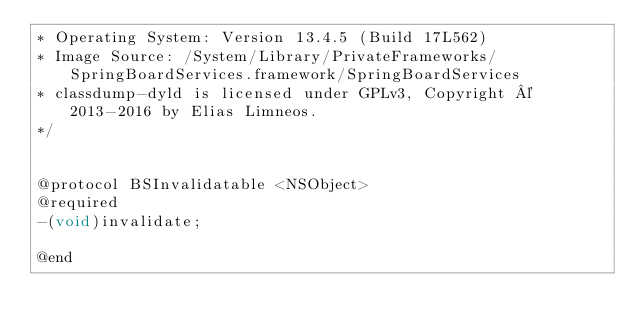Convert code to text. <code><loc_0><loc_0><loc_500><loc_500><_C_>* Operating System: Version 13.4.5 (Build 17L562)
* Image Source: /System/Library/PrivateFrameworks/SpringBoardServices.framework/SpringBoardServices
* classdump-dyld is licensed under GPLv3, Copyright © 2013-2016 by Elias Limneos.
*/


@protocol BSInvalidatable <NSObject>
@required
-(void)invalidate;

@end

</code> 